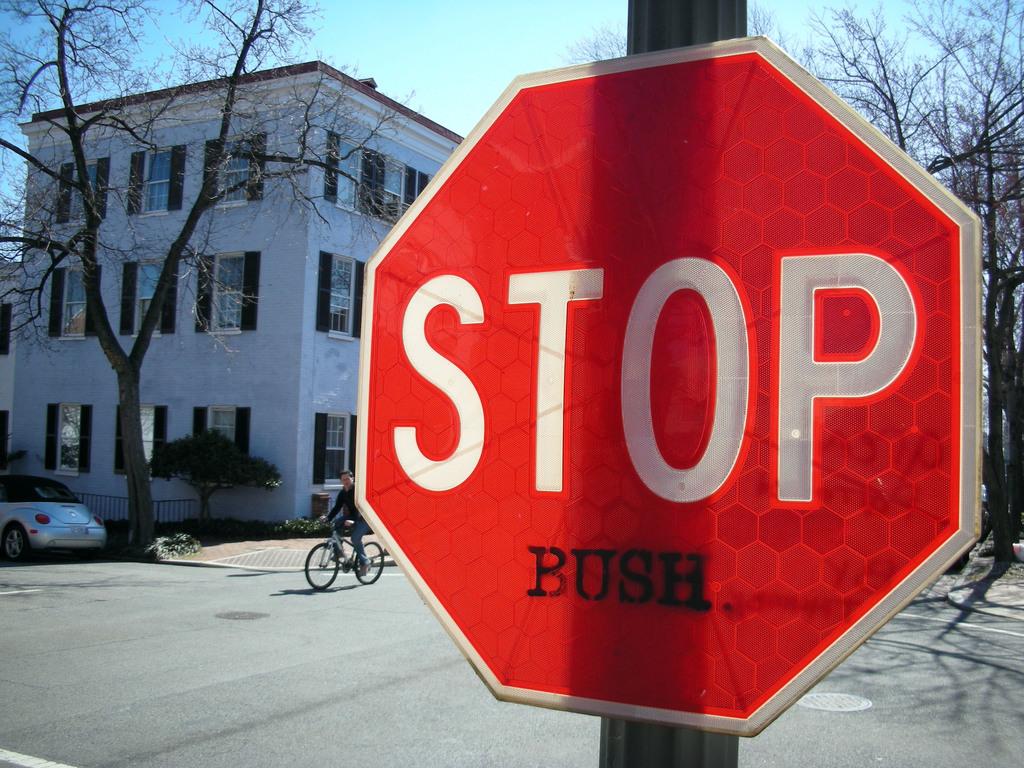Who do they want to stop?
Provide a short and direct response. Bush. What type of sign is shown?
Keep it short and to the point. Stop. 